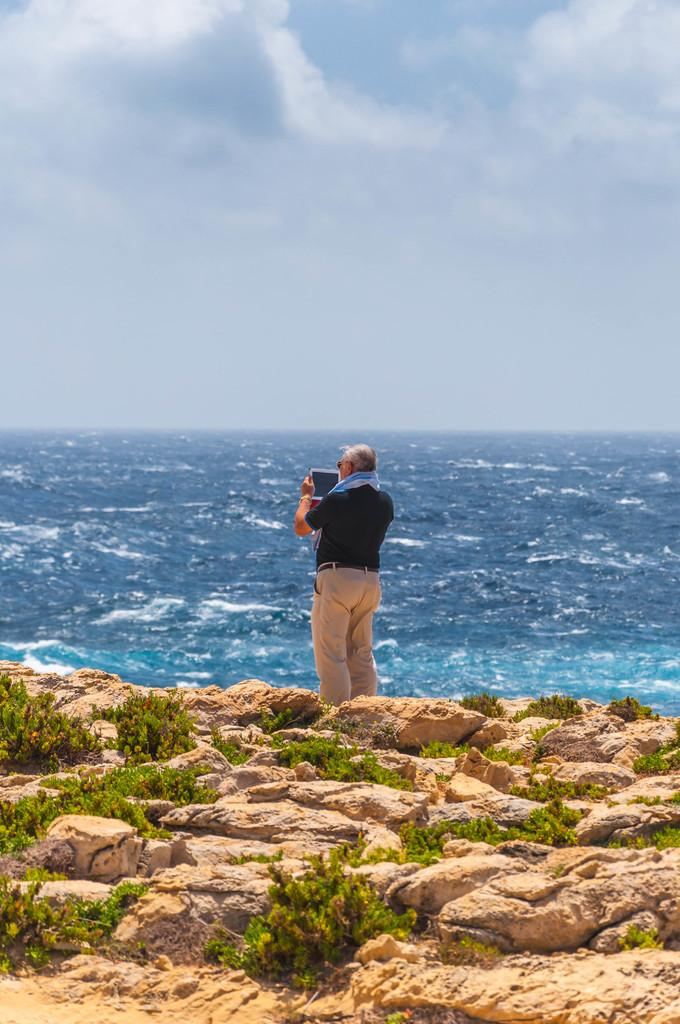What is the main subject of the image? There is a person in the image. What is the person holding in the image? The person is holding an object. What type of natural elements can be seen in the image? There are stones, plants, and water visible in the image. What is visible in the background of the image? The sky is visible in the image, and clouds are present in the sky. What is the weight of the deer in the image? There is no deer present in the image, so its weight cannot be determined. What verse is being recited by the person in the image? There is no indication in the image that the person is reciting a verse, so it cannot be determined from the picture. 